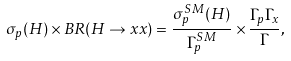<formula> <loc_0><loc_0><loc_500><loc_500>\sigma _ { p } ( H ) \times B R ( H \rightarrow x x ) = \frac { \sigma _ { p } ^ { S M } ( H ) } { \Gamma _ { p } ^ { S M } } \times \frac { \Gamma _ { p } \Gamma _ { x } } { \Gamma } ,</formula> 